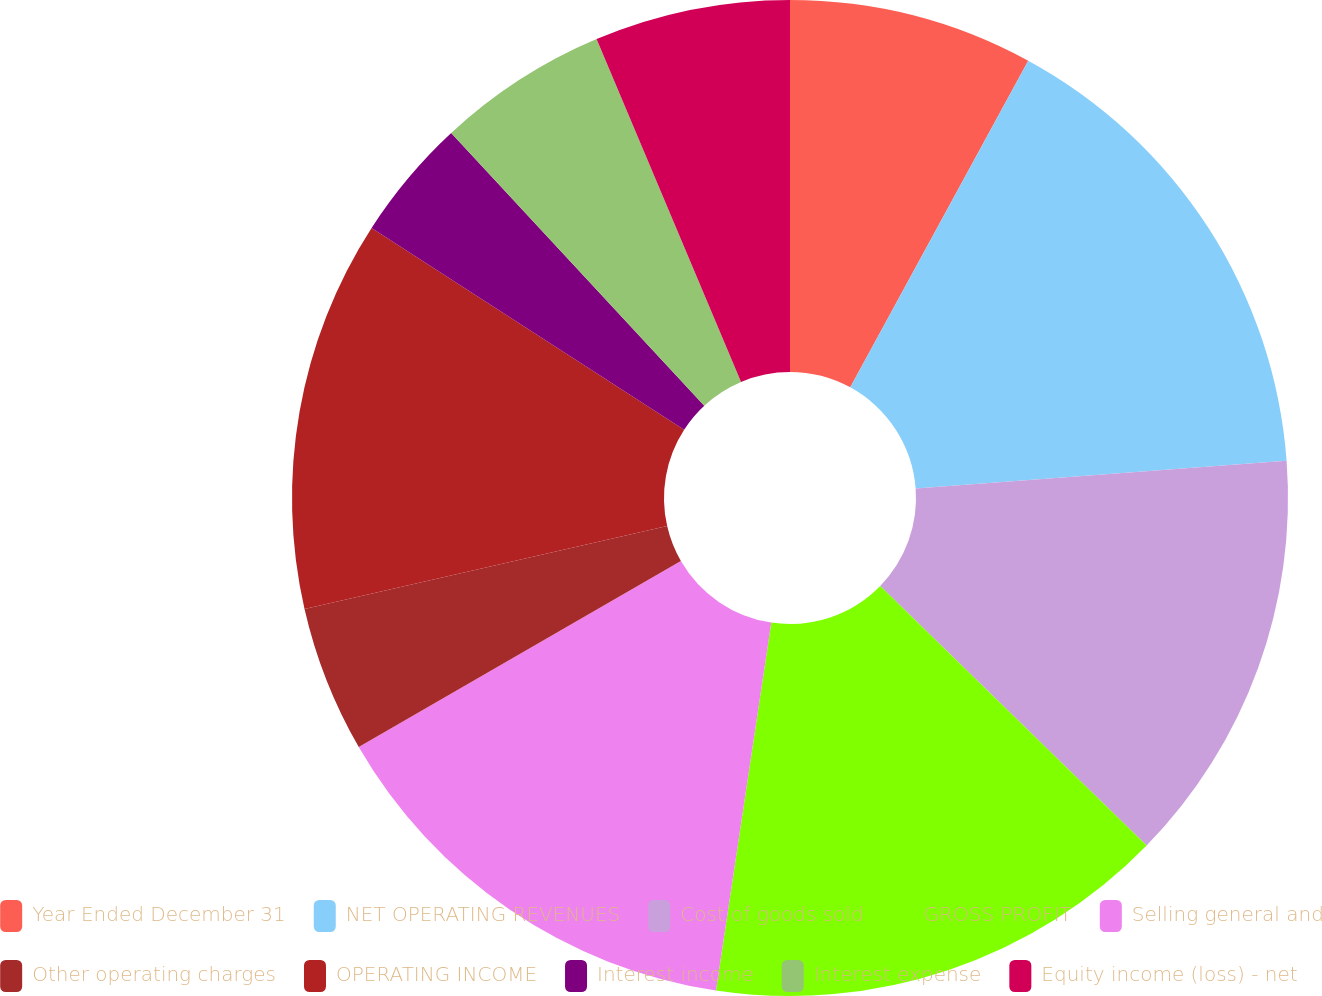Convert chart to OTSL. <chart><loc_0><loc_0><loc_500><loc_500><pie_chart><fcel>Year Ended December 31<fcel>NET OPERATING REVENUES<fcel>Cost of goods sold<fcel>GROSS PROFIT<fcel>Selling general and<fcel>Other operating charges<fcel>OPERATING INCOME<fcel>Interest income<fcel>Interest expense<fcel>Equity income (loss) - net<nl><fcel>7.94%<fcel>15.87%<fcel>13.49%<fcel>15.08%<fcel>14.29%<fcel>4.76%<fcel>12.7%<fcel>3.97%<fcel>5.56%<fcel>6.35%<nl></chart> 